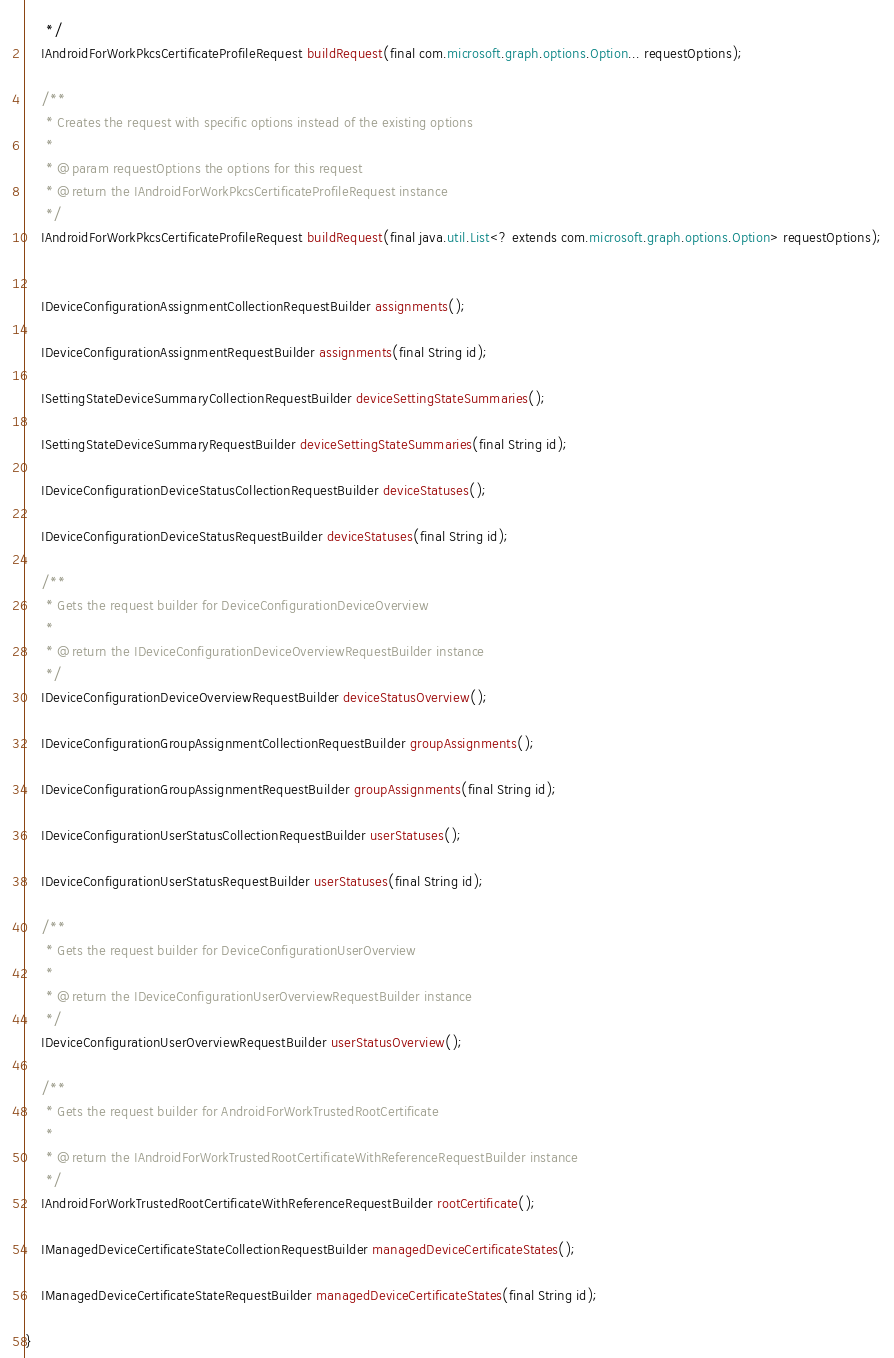Convert code to text. <code><loc_0><loc_0><loc_500><loc_500><_Java_>     */
    IAndroidForWorkPkcsCertificateProfileRequest buildRequest(final com.microsoft.graph.options.Option... requestOptions);

    /**
     * Creates the request with specific options instead of the existing options
     *
     * @param requestOptions the options for this request
     * @return the IAndroidForWorkPkcsCertificateProfileRequest instance
     */
    IAndroidForWorkPkcsCertificateProfileRequest buildRequest(final java.util.List<? extends com.microsoft.graph.options.Option> requestOptions);


    IDeviceConfigurationAssignmentCollectionRequestBuilder assignments();

    IDeviceConfigurationAssignmentRequestBuilder assignments(final String id);

    ISettingStateDeviceSummaryCollectionRequestBuilder deviceSettingStateSummaries();

    ISettingStateDeviceSummaryRequestBuilder deviceSettingStateSummaries(final String id);

    IDeviceConfigurationDeviceStatusCollectionRequestBuilder deviceStatuses();

    IDeviceConfigurationDeviceStatusRequestBuilder deviceStatuses(final String id);

    /**
     * Gets the request builder for DeviceConfigurationDeviceOverview
     *
     * @return the IDeviceConfigurationDeviceOverviewRequestBuilder instance
     */
    IDeviceConfigurationDeviceOverviewRequestBuilder deviceStatusOverview();

    IDeviceConfigurationGroupAssignmentCollectionRequestBuilder groupAssignments();

    IDeviceConfigurationGroupAssignmentRequestBuilder groupAssignments(final String id);

    IDeviceConfigurationUserStatusCollectionRequestBuilder userStatuses();

    IDeviceConfigurationUserStatusRequestBuilder userStatuses(final String id);

    /**
     * Gets the request builder for DeviceConfigurationUserOverview
     *
     * @return the IDeviceConfigurationUserOverviewRequestBuilder instance
     */
    IDeviceConfigurationUserOverviewRequestBuilder userStatusOverview();

    /**
     * Gets the request builder for AndroidForWorkTrustedRootCertificate
     *
     * @return the IAndroidForWorkTrustedRootCertificateWithReferenceRequestBuilder instance
     */
    IAndroidForWorkTrustedRootCertificateWithReferenceRequestBuilder rootCertificate();

    IManagedDeviceCertificateStateCollectionRequestBuilder managedDeviceCertificateStates();

    IManagedDeviceCertificateStateRequestBuilder managedDeviceCertificateStates(final String id);

}</code> 